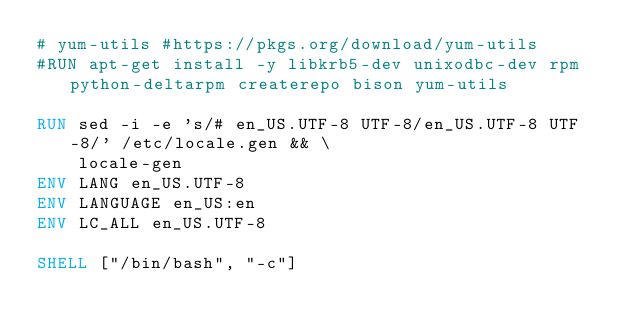Convert code to text. <code><loc_0><loc_0><loc_500><loc_500><_Dockerfile_># yum-utils #https://pkgs.org/download/yum-utils
#RUN apt-get install -y libkrb5-dev unixodbc-dev rpm python-deltarpm createrepo bison yum-utils

RUN sed -i -e 's/# en_US.UTF-8 UTF-8/en_US.UTF-8 UTF-8/' /etc/locale.gen && \
    locale-gen
ENV LANG en_US.UTF-8  
ENV LANGUAGE en_US:en  
ENV LC_ALL en_US.UTF-8 

SHELL ["/bin/bash", "-c"]
</code> 